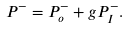Convert formula to latex. <formula><loc_0><loc_0><loc_500><loc_500>P ^ { - } = P ^ { - } _ { o } + g P _ { I } ^ { - } .</formula> 